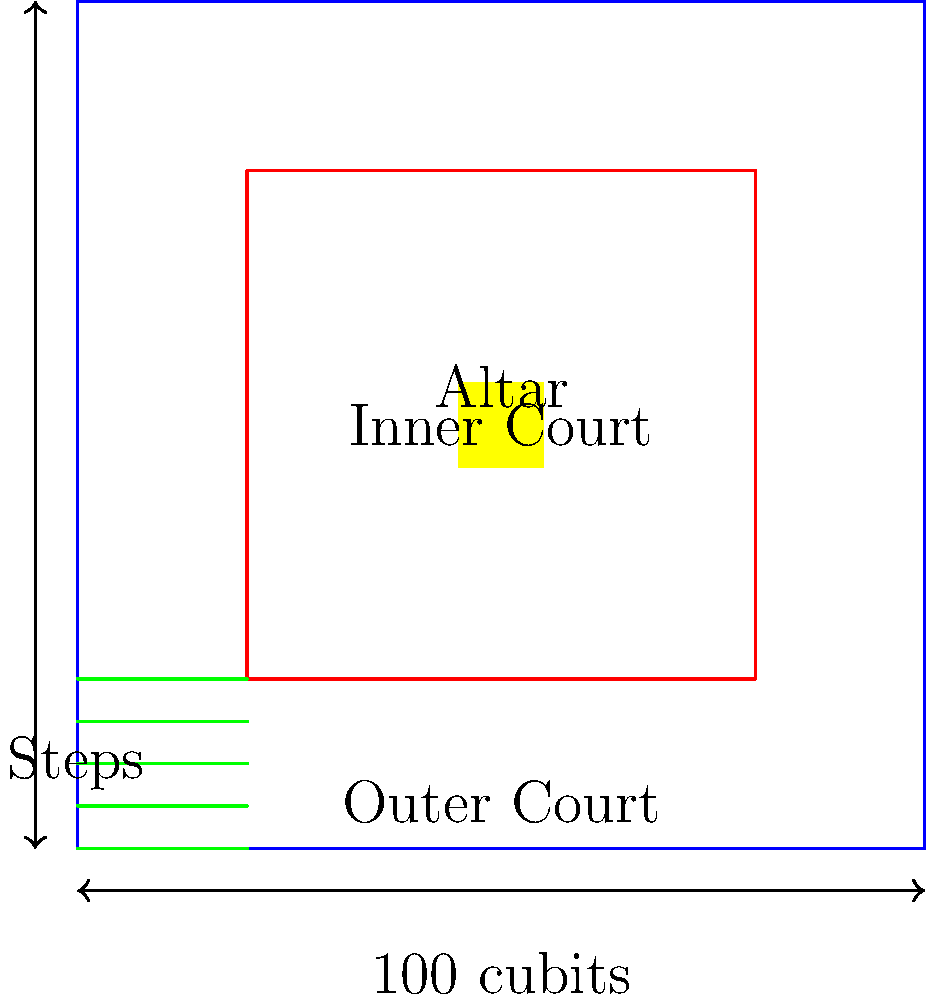According to Ezekiel's vision of the Third Temple, what is the dimension of the outer court, and how does it relate to the inner court's size? To answer this question, we need to examine Ezekiel's detailed description of the Third Temple:

1. Ezekiel 40:47 describes the outer court: "Then he measured the court: it was square, one hundred cubits long and one hundred cubits wide."

2. The inner court is described in Ezekiel 40:19: "Then he measured the distance from the front of the lower gateway to the outer front of the inner court; it was one hundred cubits on the east side and on the north side."

3. This indicates that the outer court forms a perfect square, measuring 100 cubits on each side.

4. The inner court is positioned within the outer court, also forming a square shape.

5. The space between the outer and inner courts is equal on all sides, creating a symmetrical layout.

6. This design reflects the importance of symmetry and precise measurements in the Temple's architecture, emphasizing its divine origin and spiritual significance.

7. The equal dimensions of 100 cubits for both the outer and inner courts symbolize perfection and completeness in Jewish mystical thought.

Therefore, the outer court is a square measuring 100 cubits on each side, and it perfectly encompasses the inner court, maintaining equal distances on all sides.
Answer: 100 cubits square, perfectly encompassing the inner court 